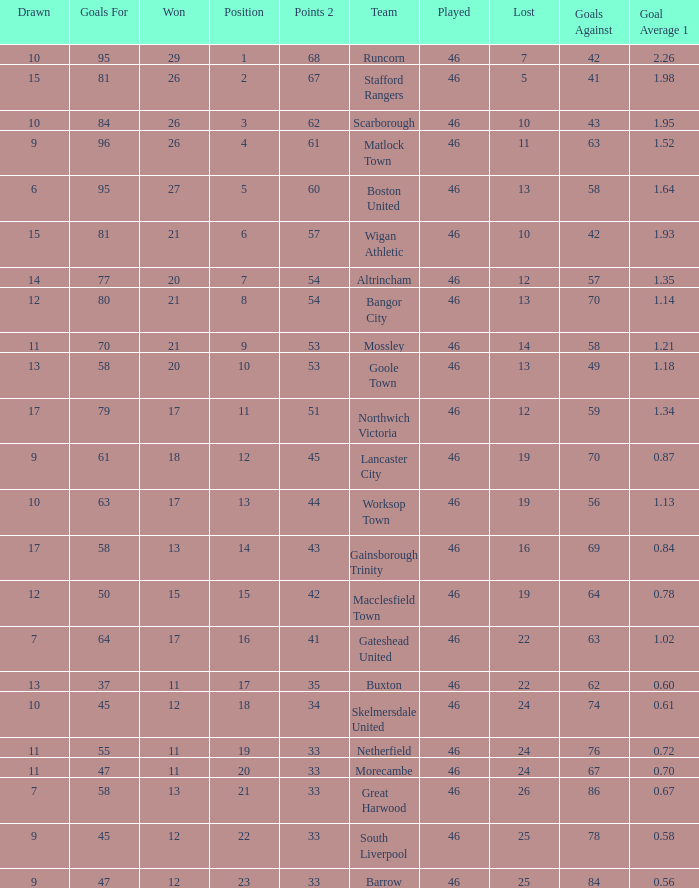How many times did the Lancaster City team play? 1.0. 